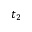Convert formula to latex. <formula><loc_0><loc_0><loc_500><loc_500>t _ { 2 }</formula> 